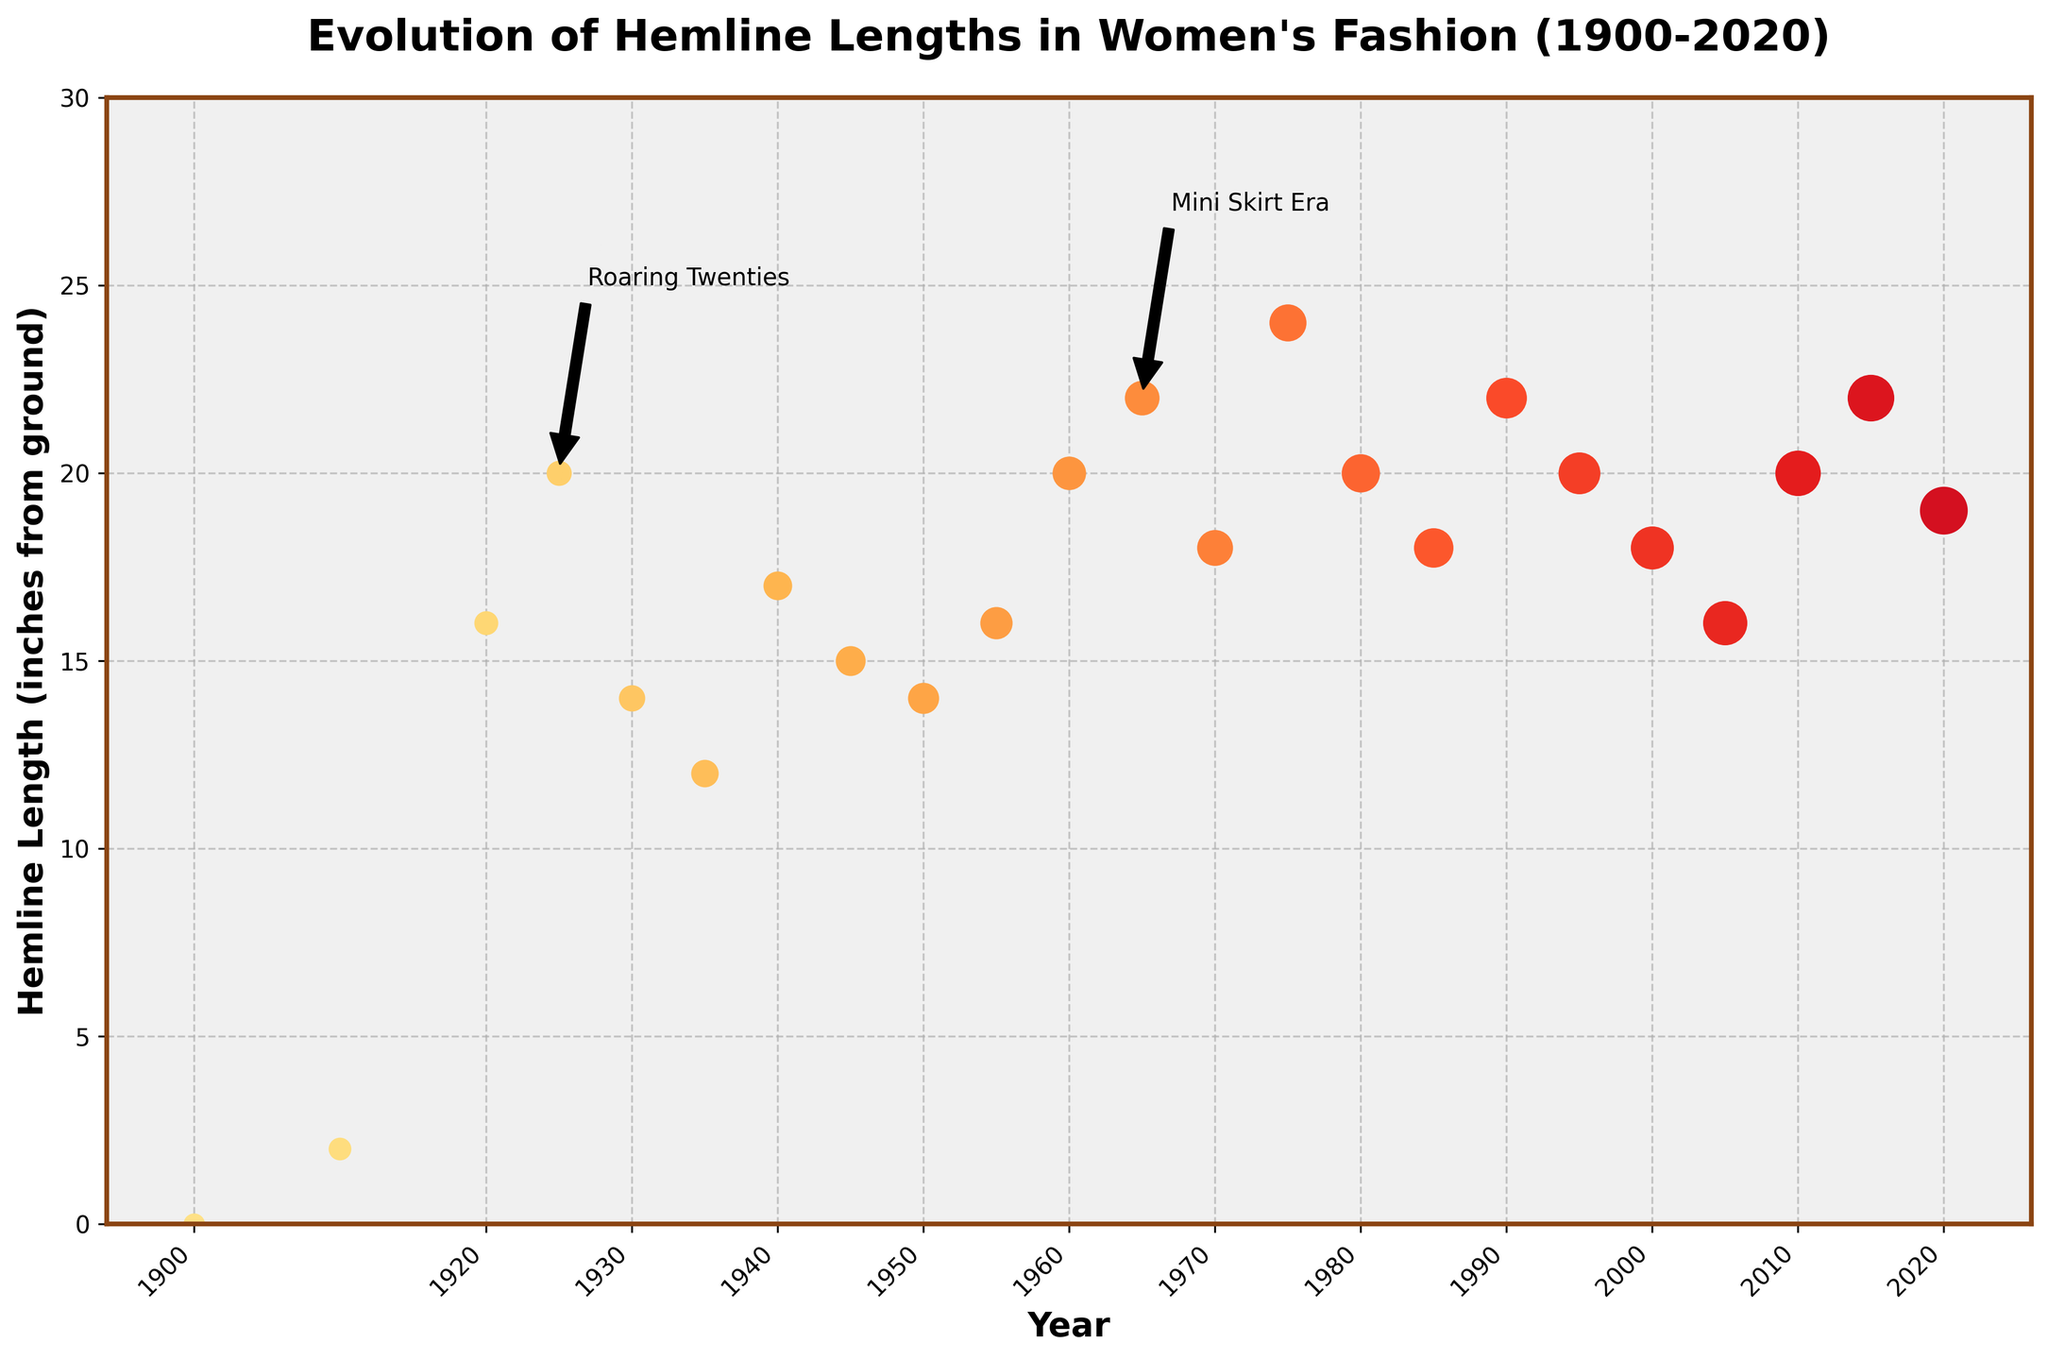What historical period is annotated with an arrow pointing to the hemline at 1925? The figure shows an arrow pointing to the hemline at 1925 labeled "Roaring Twenties".
Answer: Roaring Twenties During which year did the hemline length first reach 22 inches? The plot has annotations for key periods, and the first time the hemline reaches 22 inches is in 1965, confirmed by the "Mini Skirt Era" annotation.
Answer: 1965 How much did the hemline length change from 1910 to 1920? To find the change in hemline length, subtract the length in 1910 (2 inches) from the length in 1920 (16 inches), resulting in a change of 14 inches.
Answer: 14 inches What is the trend of hemline length between 1970 to 1975? Observing the plot, the hemline length increased from 18 inches in 1970 to 24 inches in 1975, indicating an upward trend.
Answer: Upward trend Compare the hemline length in 1950 and 2010. Which year had the shorter hemline? Observing the hemline lengths for 1950 (14 inches) and 2010 (20 inches), it is clear that 1950 had the shorter hemline.
Answer: 1950 What is the average hemline length from 2000 to 2020? The hemline lengths for the years 2000, 2005, 2010, 2015, and 2020 are 18, 16, 20, 22, and 19 inches respectively. Their average is calculated as (18 + 16 + 20 + 22 + 19) / 5 = 95 / 5 = 19 inches.
Answer: 19 inches Between which adjacent pairs of years is the largest increase in hemline length observed? Checking the plot, the largest increase is between 1910 (2 inches) and 1920 (16 inches) with a difference of 14 inches.
Answer: Between 1910 and 1920 During which decade did hemline lengths consistently rise? Examining the decade-wise data, hemline lengths consistently rose during the 1920s, specifically peaking in 1925.
Answer: 1920s Which year had a higher hemline length: 1980 or 1975? The plot shows the hemline length in 1980 as 20 inches and 1975 as 24 inches. Thus, 1975 had a higher hemline length.
Answer: 1975 